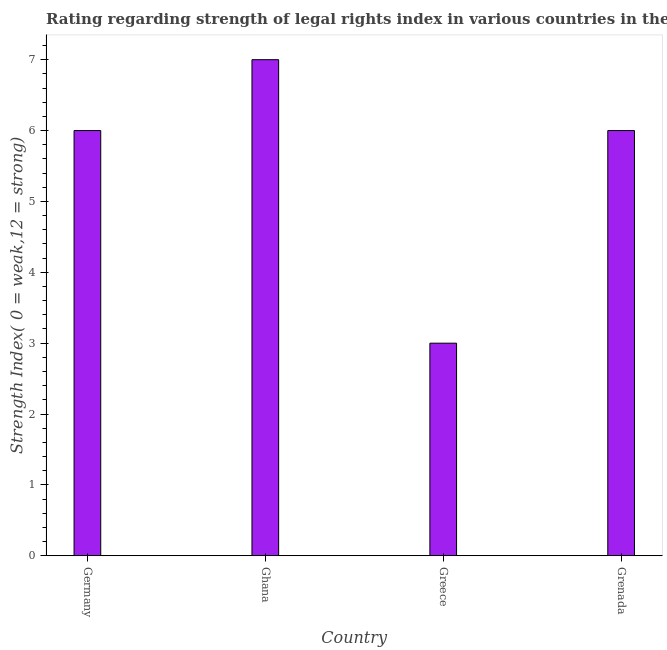Does the graph contain any zero values?
Your response must be concise. No. What is the title of the graph?
Give a very brief answer. Rating regarding strength of legal rights index in various countries in the year 2013. What is the label or title of the Y-axis?
Offer a very short reply. Strength Index( 0 = weak,12 = strong). What is the strength of legal rights index in Ghana?
Keep it short and to the point. 7. Across all countries, what is the minimum strength of legal rights index?
Offer a terse response. 3. In which country was the strength of legal rights index maximum?
Provide a short and direct response. Ghana. What is the sum of the strength of legal rights index?
Offer a terse response. 22. In how many countries, is the strength of legal rights index greater than 5.6 ?
Your response must be concise. 3. What is the ratio of the strength of legal rights index in Ghana to that in Grenada?
Your response must be concise. 1.17. Is the strength of legal rights index in Germany less than that in Ghana?
Provide a succinct answer. Yes. Is the difference between the strength of legal rights index in Germany and Greece greater than the difference between any two countries?
Your response must be concise. No. What is the difference between the highest and the lowest strength of legal rights index?
Give a very brief answer. 4. In how many countries, is the strength of legal rights index greater than the average strength of legal rights index taken over all countries?
Offer a terse response. 3. How many bars are there?
Offer a terse response. 4. How many countries are there in the graph?
Make the answer very short. 4. What is the Strength Index( 0 = weak,12 = strong) in Germany?
Ensure brevity in your answer.  6. What is the Strength Index( 0 = weak,12 = strong) of Ghana?
Provide a succinct answer. 7. What is the difference between the Strength Index( 0 = weak,12 = strong) in Germany and Ghana?
Your answer should be compact. -1. What is the difference between the Strength Index( 0 = weak,12 = strong) in Germany and Grenada?
Your answer should be very brief. 0. What is the difference between the Strength Index( 0 = weak,12 = strong) in Ghana and Greece?
Offer a terse response. 4. What is the difference between the Strength Index( 0 = weak,12 = strong) in Ghana and Grenada?
Give a very brief answer. 1. What is the difference between the Strength Index( 0 = weak,12 = strong) in Greece and Grenada?
Your answer should be very brief. -3. What is the ratio of the Strength Index( 0 = weak,12 = strong) in Germany to that in Ghana?
Ensure brevity in your answer.  0.86. What is the ratio of the Strength Index( 0 = weak,12 = strong) in Germany to that in Greece?
Offer a very short reply. 2. What is the ratio of the Strength Index( 0 = weak,12 = strong) in Germany to that in Grenada?
Provide a succinct answer. 1. What is the ratio of the Strength Index( 0 = weak,12 = strong) in Ghana to that in Greece?
Your answer should be compact. 2.33. What is the ratio of the Strength Index( 0 = weak,12 = strong) in Ghana to that in Grenada?
Your answer should be compact. 1.17. 